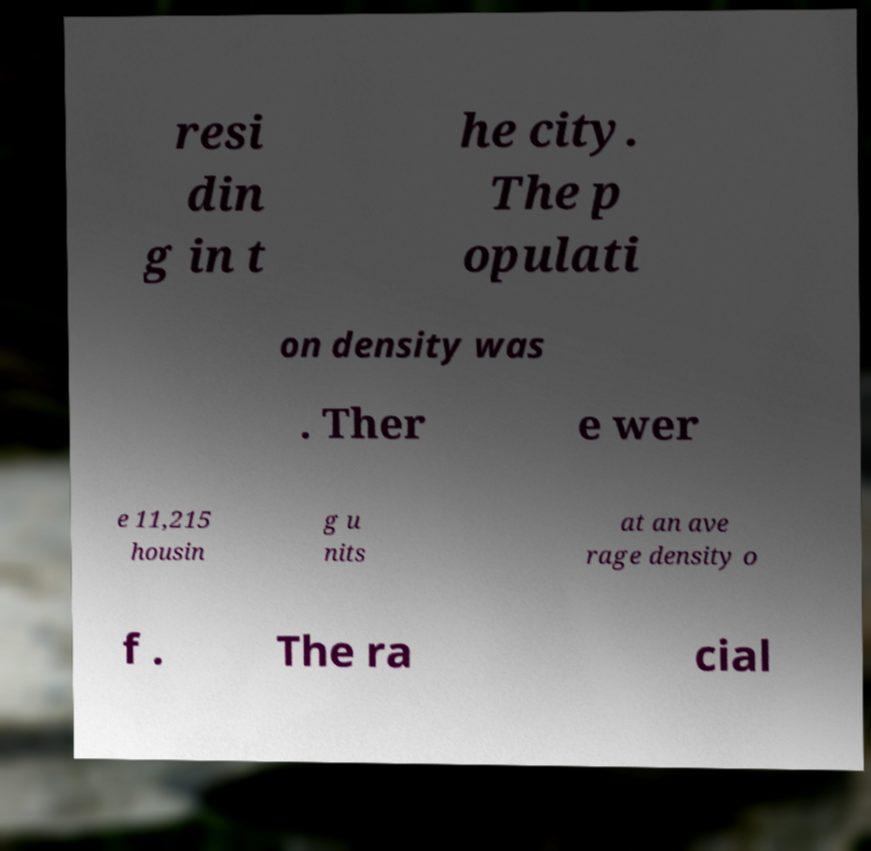Could you assist in decoding the text presented in this image and type it out clearly? resi din g in t he city. The p opulati on density was . Ther e wer e 11,215 housin g u nits at an ave rage density o f . The ra cial 